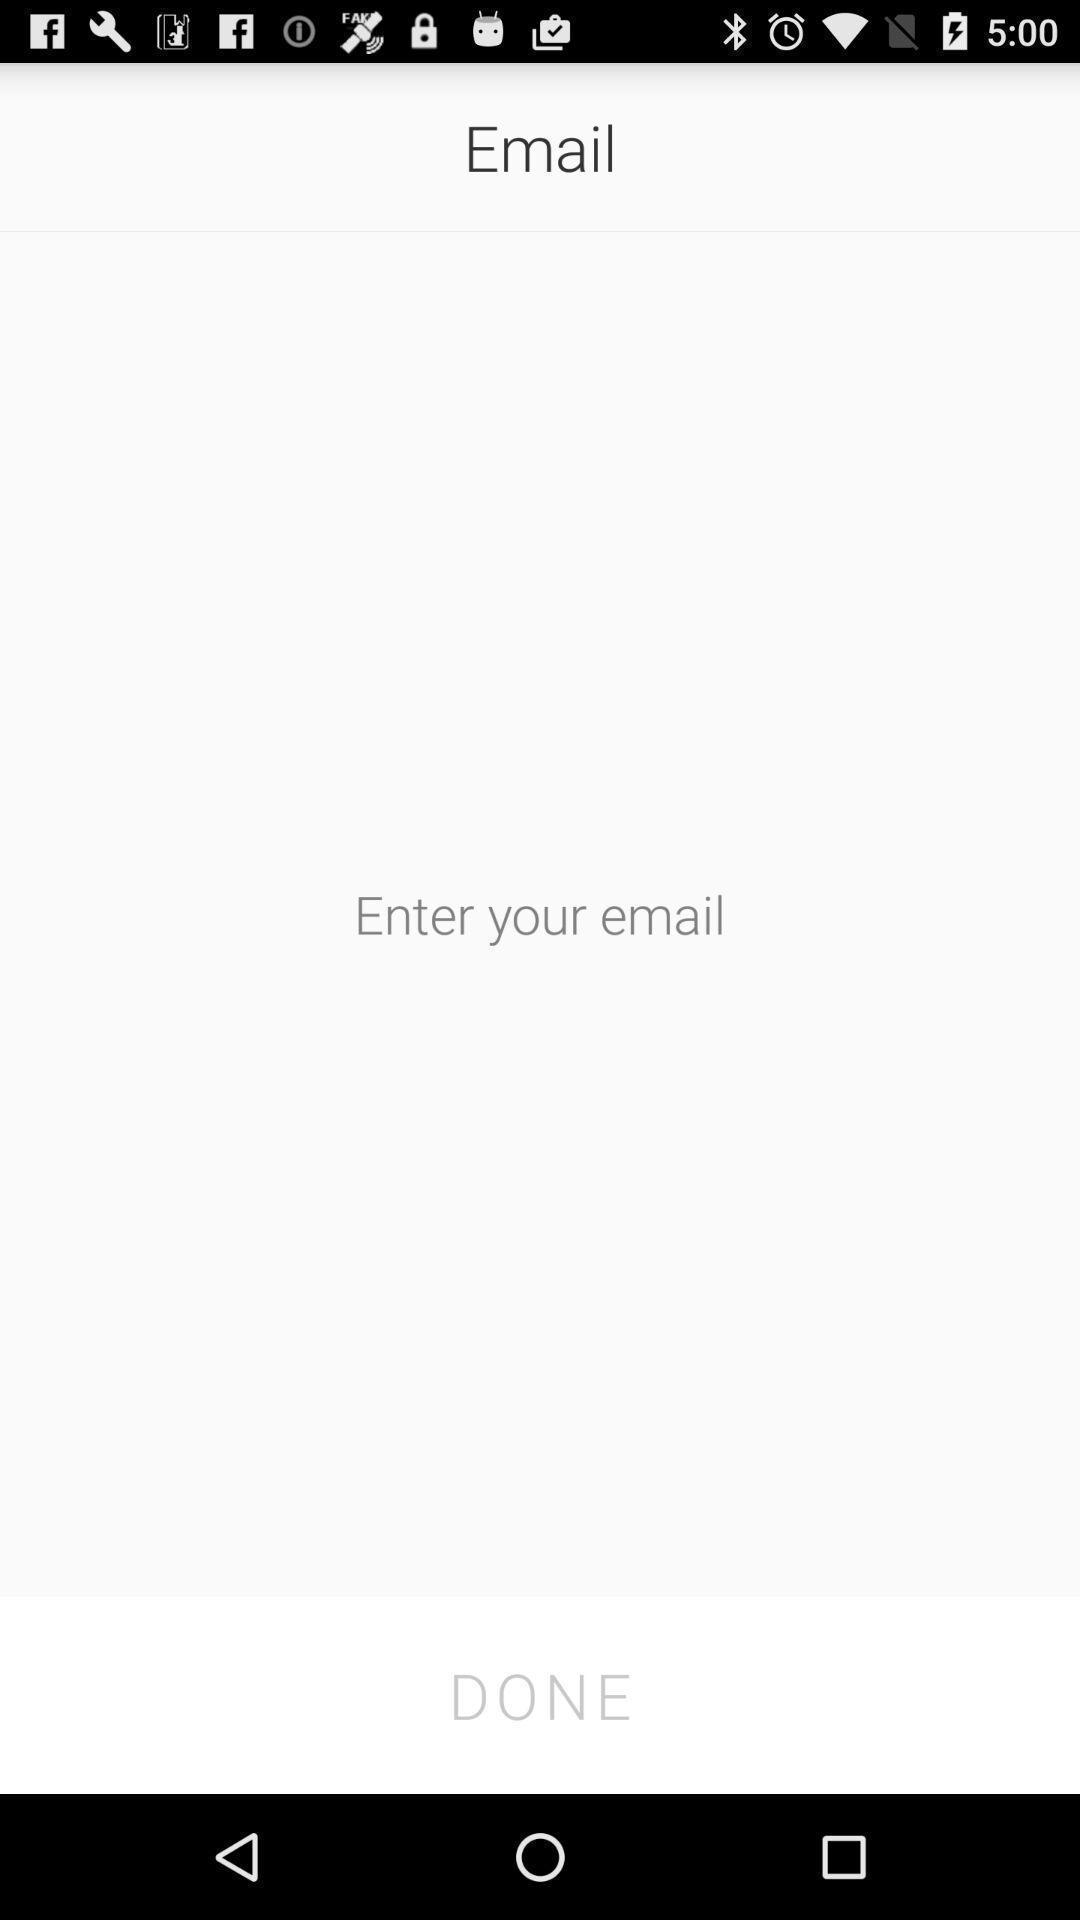What details can you identify in this image? Page to enter your mail in a navigation app. 